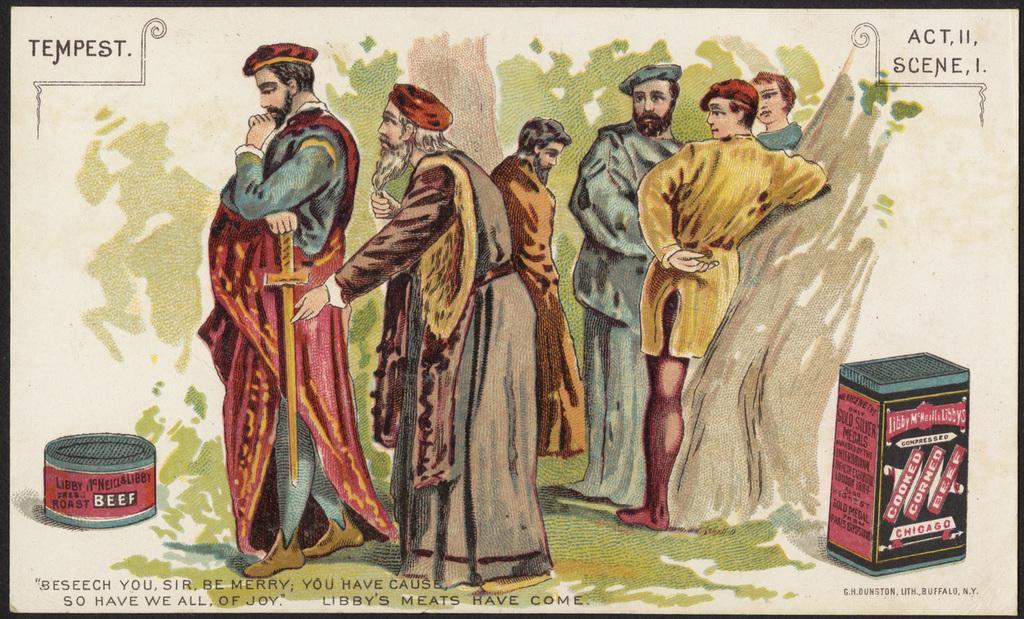Please provide a concise description of this image. In this image I can see a poster. There is a drawing of people standing and there are trees at the back. There are 2 boxes and some matter written at the bottom. 